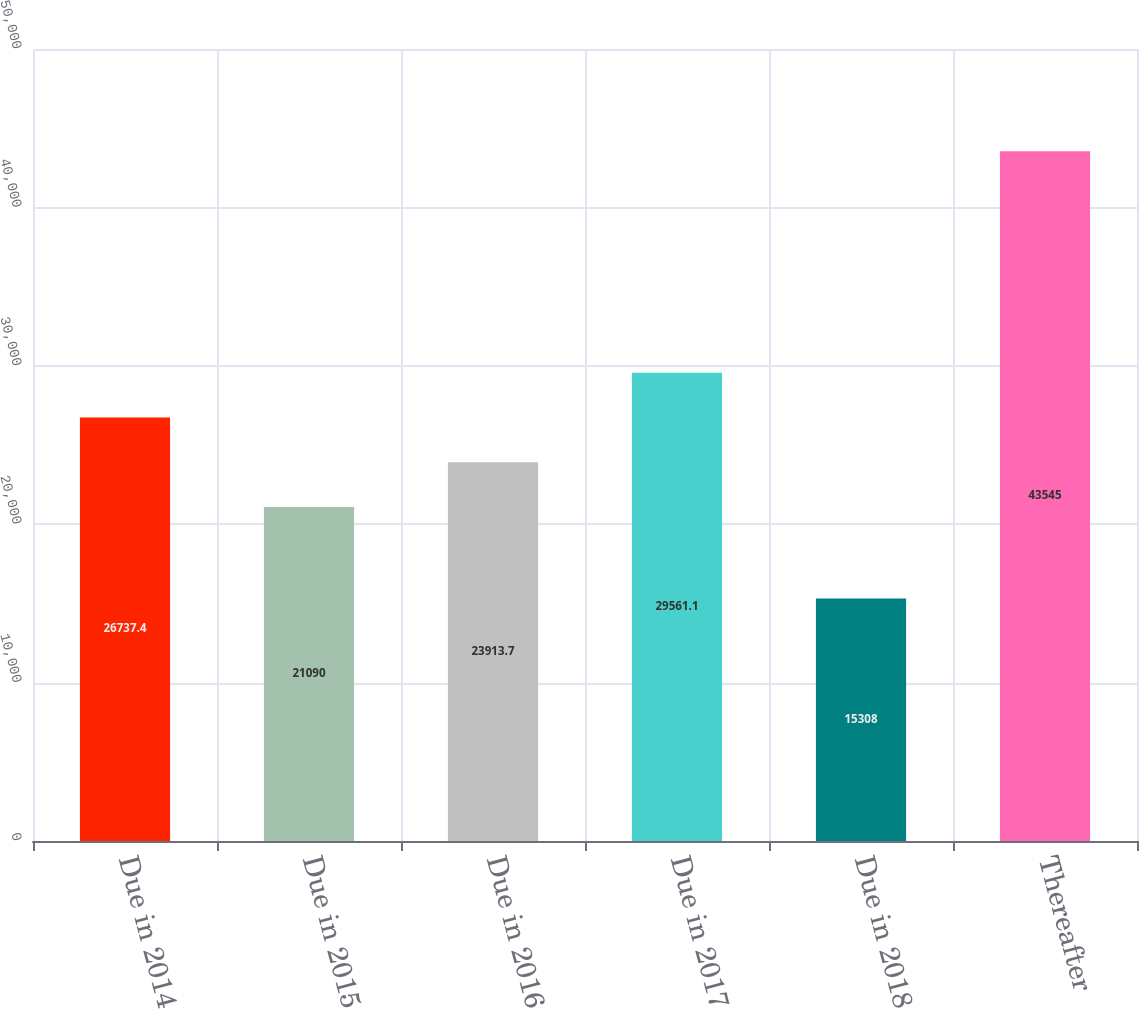Convert chart. <chart><loc_0><loc_0><loc_500><loc_500><bar_chart><fcel>Due in 2014<fcel>Due in 2015<fcel>Due in 2016<fcel>Due in 2017<fcel>Due in 2018<fcel>Thereafter<nl><fcel>26737.4<fcel>21090<fcel>23913.7<fcel>29561.1<fcel>15308<fcel>43545<nl></chart> 